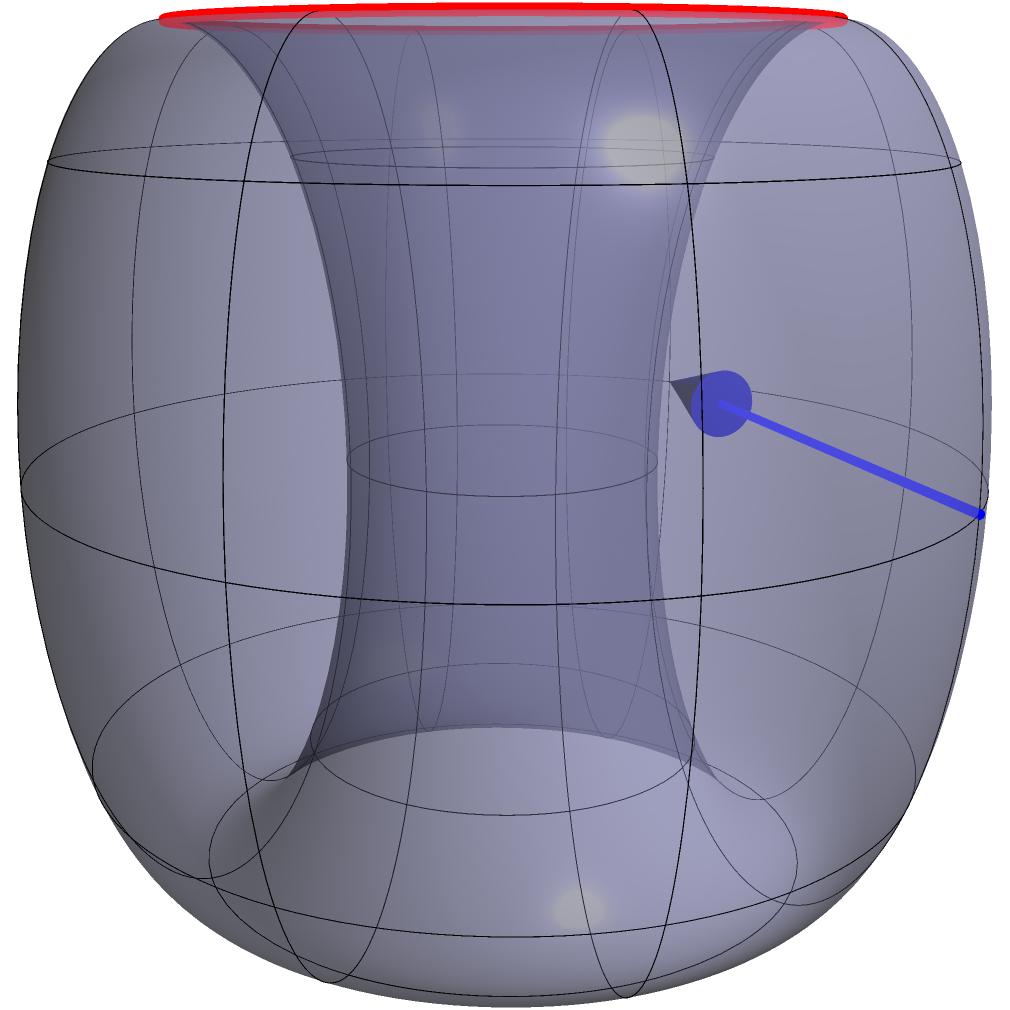Consider parallel transport of a vector along the closed loop shown in red on the torus surface. If the initial vector is tangent to the torus and perpendicular to the loop, what is the angle (in radians) between the initial and final vectors after one complete traversal of the loop? To solve this problem, we need to understand the concept of parallel transport on a curved surface and apply it to the specific case of a torus:

1. The torus has two principal radii: $R$ (the distance from the center of the tube to the center of the torus) and $r$ (the radius of the tube).

2. The loop shown is a latitude circle of the torus, with a constant "height" on the surface.

3. For parallel transport along this loop, we need to consider the solid angle subtended by the loop at the center of the torus.

4. The solid angle $\Omega$ subtended by a latitude circle on a torus is given by:

   $$\Omega = 2\pi(1 - \cos\theta)$$

   where $\theta$ is the angle between the radius to the center of the loop and the axis of the torus.

5. In this case, $\cos\theta = \frac{r}{R+r}$, as the loop is at the "equator" of the torus.

6. Substituting this into the solid angle formula:

   $$\Omega = 2\pi(1 - \frac{r}{R+r}) = 2\pi(\frac{R}{R+r})$$

7. The angle of rotation of the vector after parallel transport around a closed loop is equal to the solid angle subtended by the loop.

8. Therefore, the angle between the initial and final vectors is:

   $$\text{Angle} = 2\pi(\frac{R}{R+r})$$

9. Given that $R=2$ and $r=1$ (as shown in the Asymptote code), we can calculate:

   $$\text{Angle} = 2\pi(\frac{2}{2+1}) = 2\pi(\frac{2}{3}) = \frac{4\pi}{3}$$
Answer: $\frac{4\pi}{3}$ radians 